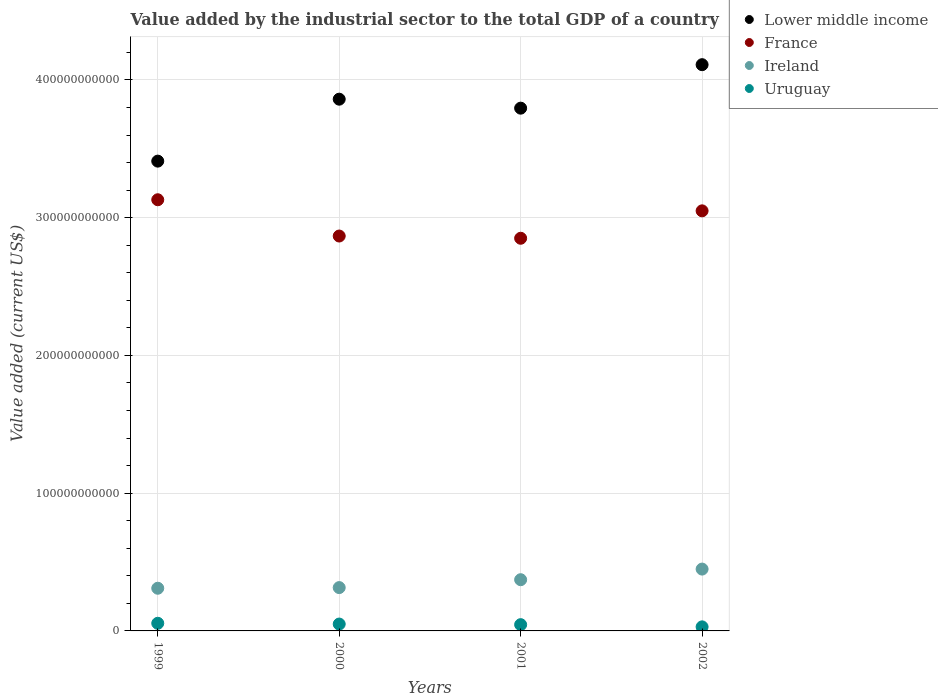How many different coloured dotlines are there?
Offer a terse response. 4. What is the value added by the industrial sector to the total GDP in Lower middle income in 2001?
Offer a terse response. 3.79e+11. Across all years, what is the maximum value added by the industrial sector to the total GDP in Lower middle income?
Keep it short and to the point. 4.11e+11. Across all years, what is the minimum value added by the industrial sector to the total GDP in Uruguay?
Provide a succinct answer. 2.95e+09. In which year was the value added by the industrial sector to the total GDP in Uruguay maximum?
Offer a terse response. 1999. In which year was the value added by the industrial sector to the total GDP in France minimum?
Ensure brevity in your answer.  2001. What is the total value added by the industrial sector to the total GDP in Uruguay in the graph?
Provide a succinct answer. 1.80e+1. What is the difference between the value added by the industrial sector to the total GDP in Lower middle income in 1999 and that in 2002?
Offer a very short reply. -7.00e+1. What is the difference between the value added by the industrial sector to the total GDP in Uruguay in 2002 and the value added by the industrial sector to the total GDP in Lower middle income in 1999?
Offer a very short reply. -3.38e+11. What is the average value added by the industrial sector to the total GDP in Uruguay per year?
Make the answer very short. 4.50e+09. In the year 2001, what is the difference between the value added by the industrial sector to the total GDP in Lower middle income and value added by the industrial sector to the total GDP in France?
Your response must be concise. 9.44e+1. What is the ratio of the value added by the industrial sector to the total GDP in Ireland in 1999 to that in 2001?
Your answer should be compact. 0.83. Is the value added by the industrial sector to the total GDP in Uruguay in 1999 less than that in 2000?
Your answer should be compact. No. What is the difference between the highest and the second highest value added by the industrial sector to the total GDP in Ireland?
Give a very brief answer. 7.71e+09. What is the difference between the highest and the lowest value added by the industrial sector to the total GDP in Uruguay?
Provide a succinct answer. 2.59e+09. Is the sum of the value added by the industrial sector to the total GDP in Lower middle income in 1999 and 2002 greater than the maximum value added by the industrial sector to the total GDP in France across all years?
Your response must be concise. Yes. Is it the case that in every year, the sum of the value added by the industrial sector to the total GDP in Lower middle income and value added by the industrial sector to the total GDP in France  is greater than the sum of value added by the industrial sector to the total GDP in Ireland and value added by the industrial sector to the total GDP in Uruguay?
Ensure brevity in your answer.  Yes. Is it the case that in every year, the sum of the value added by the industrial sector to the total GDP in Uruguay and value added by the industrial sector to the total GDP in France  is greater than the value added by the industrial sector to the total GDP in Ireland?
Ensure brevity in your answer.  Yes. Does the value added by the industrial sector to the total GDP in France monotonically increase over the years?
Provide a short and direct response. No. Is the value added by the industrial sector to the total GDP in Lower middle income strictly less than the value added by the industrial sector to the total GDP in Uruguay over the years?
Offer a terse response. No. What is the difference between two consecutive major ticks on the Y-axis?
Your answer should be very brief. 1.00e+11. Does the graph contain any zero values?
Provide a succinct answer. No. How are the legend labels stacked?
Your answer should be compact. Vertical. What is the title of the graph?
Provide a short and direct response. Value added by the industrial sector to the total GDP of a country. What is the label or title of the Y-axis?
Keep it short and to the point. Value added (current US$). What is the Value added (current US$) of Lower middle income in 1999?
Give a very brief answer. 3.41e+11. What is the Value added (current US$) in France in 1999?
Your response must be concise. 3.13e+11. What is the Value added (current US$) in Ireland in 1999?
Give a very brief answer. 3.10e+1. What is the Value added (current US$) of Uruguay in 1999?
Offer a terse response. 5.54e+09. What is the Value added (current US$) of Lower middle income in 2000?
Make the answer very short. 3.86e+11. What is the Value added (current US$) in France in 2000?
Make the answer very short. 2.87e+11. What is the Value added (current US$) in Ireland in 2000?
Offer a very short reply. 3.15e+1. What is the Value added (current US$) in Uruguay in 2000?
Keep it short and to the point. 4.98e+09. What is the Value added (current US$) of Lower middle income in 2001?
Give a very brief answer. 3.79e+11. What is the Value added (current US$) in France in 2001?
Give a very brief answer. 2.85e+11. What is the Value added (current US$) of Ireland in 2001?
Ensure brevity in your answer.  3.72e+1. What is the Value added (current US$) in Uruguay in 2001?
Your answer should be very brief. 4.54e+09. What is the Value added (current US$) of Lower middle income in 2002?
Your response must be concise. 4.11e+11. What is the Value added (current US$) of France in 2002?
Offer a very short reply. 3.05e+11. What is the Value added (current US$) of Ireland in 2002?
Ensure brevity in your answer.  4.49e+1. What is the Value added (current US$) of Uruguay in 2002?
Keep it short and to the point. 2.95e+09. Across all years, what is the maximum Value added (current US$) in Lower middle income?
Your answer should be very brief. 4.11e+11. Across all years, what is the maximum Value added (current US$) of France?
Offer a terse response. 3.13e+11. Across all years, what is the maximum Value added (current US$) in Ireland?
Your answer should be compact. 4.49e+1. Across all years, what is the maximum Value added (current US$) in Uruguay?
Offer a very short reply. 5.54e+09. Across all years, what is the minimum Value added (current US$) of Lower middle income?
Provide a succinct answer. 3.41e+11. Across all years, what is the minimum Value added (current US$) in France?
Offer a very short reply. 2.85e+11. Across all years, what is the minimum Value added (current US$) of Ireland?
Offer a terse response. 3.10e+1. Across all years, what is the minimum Value added (current US$) in Uruguay?
Provide a succinct answer. 2.95e+09. What is the total Value added (current US$) of Lower middle income in the graph?
Give a very brief answer. 1.52e+12. What is the total Value added (current US$) of France in the graph?
Provide a short and direct response. 1.19e+12. What is the total Value added (current US$) of Ireland in the graph?
Give a very brief answer. 1.45e+11. What is the total Value added (current US$) in Uruguay in the graph?
Ensure brevity in your answer.  1.80e+1. What is the difference between the Value added (current US$) in Lower middle income in 1999 and that in 2000?
Provide a succinct answer. -4.50e+1. What is the difference between the Value added (current US$) in France in 1999 and that in 2000?
Make the answer very short. 2.63e+1. What is the difference between the Value added (current US$) of Ireland in 1999 and that in 2000?
Your answer should be very brief. -4.74e+08. What is the difference between the Value added (current US$) of Uruguay in 1999 and that in 2000?
Give a very brief answer. 5.58e+08. What is the difference between the Value added (current US$) of Lower middle income in 1999 and that in 2001?
Provide a succinct answer. -3.84e+1. What is the difference between the Value added (current US$) of France in 1999 and that in 2001?
Offer a very short reply. 2.80e+1. What is the difference between the Value added (current US$) in Ireland in 1999 and that in 2001?
Keep it short and to the point. -6.20e+09. What is the difference between the Value added (current US$) of Uruguay in 1999 and that in 2001?
Ensure brevity in your answer.  9.97e+08. What is the difference between the Value added (current US$) of Lower middle income in 1999 and that in 2002?
Offer a terse response. -7.00e+1. What is the difference between the Value added (current US$) of France in 1999 and that in 2002?
Your answer should be compact. 8.05e+09. What is the difference between the Value added (current US$) of Ireland in 1999 and that in 2002?
Make the answer very short. -1.39e+1. What is the difference between the Value added (current US$) in Uruguay in 1999 and that in 2002?
Offer a terse response. 2.59e+09. What is the difference between the Value added (current US$) in Lower middle income in 2000 and that in 2001?
Offer a terse response. 6.52e+09. What is the difference between the Value added (current US$) of France in 2000 and that in 2001?
Offer a very short reply. 1.62e+09. What is the difference between the Value added (current US$) of Ireland in 2000 and that in 2001?
Give a very brief answer. -5.73e+09. What is the difference between the Value added (current US$) in Uruguay in 2000 and that in 2001?
Provide a short and direct response. 4.39e+08. What is the difference between the Value added (current US$) in Lower middle income in 2000 and that in 2002?
Offer a very short reply. -2.50e+1. What is the difference between the Value added (current US$) of France in 2000 and that in 2002?
Ensure brevity in your answer.  -1.83e+1. What is the difference between the Value added (current US$) in Ireland in 2000 and that in 2002?
Provide a short and direct response. -1.34e+1. What is the difference between the Value added (current US$) in Uruguay in 2000 and that in 2002?
Give a very brief answer. 2.04e+09. What is the difference between the Value added (current US$) of Lower middle income in 2001 and that in 2002?
Ensure brevity in your answer.  -3.16e+1. What is the difference between the Value added (current US$) of France in 2001 and that in 2002?
Keep it short and to the point. -1.99e+1. What is the difference between the Value added (current US$) in Ireland in 2001 and that in 2002?
Provide a succinct answer. -7.71e+09. What is the difference between the Value added (current US$) in Uruguay in 2001 and that in 2002?
Make the answer very short. 1.60e+09. What is the difference between the Value added (current US$) of Lower middle income in 1999 and the Value added (current US$) of France in 2000?
Your response must be concise. 5.44e+1. What is the difference between the Value added (current US$) in Lower middle income in 1999 and the Value added (current US$) in Ireland in 2000?
Ensure brevity in your answer.  3.10e+11. What is the difference between the Value added (current US$) of Lower middle income in 1999 and the Value added (current US$) of Uruguay in 2000?
Offer a very short reply. 3.36e+11. What is the difference between the Value added (current US$) in France in 1999 and the Value added (current US$) in Ireland in 2000?
Make the answer very short. 2.82e+11. What is the difference between the Value added (current US$) of France in 1999 and the Value added (current US$) of Uruguay in 2000?
Offer a terse response. 3.08e+11. What is the difference between the Value added (current US$) of Ireland in 1999 and the Value added (current US$) of Uruguay in 2000?
Make the answer very short. 2.60e+1. What is the difference between the Value added (current US$) in Lower middle income in 1999 and the Value added (current US$) in France in 2001?
Your answer should be very brief. 5.60e+1. What is the difference between the Value added (current US$) of Lower middle income in 1999 and the Value added (current US$) of Ireland in 2001?
Your answer should be very brief. 3.04e+11. What is the difference between the Value added (current US$) of Lower middle income in 1999 and the Value added (current US$) of Uruguay in 2001?
Offer a terse response. 3.37e+11. What is the difference between the Value added (current US$) of France in 1999 and the Value added (current US$) of Ireland in 2001?
Give a very brief answer. 2.76e+11. What is the difference between the Value added (current US$) of France in 1999 and the Value added (current US$) of Uruguay in 2001?
Keep it short and to the point. 3.08e+11. What is the difference between the Value added (current US$) of Ireland in 1999 and the Value added (current US$) of Uruguay in 2001?
Offer a terse response. 2.64e+1. What is the difference between the Value added (current US$) of Lower middle income in 1999 and the Value added (current US$) of France in 2002?
Offer a very short reply. 3.61e+1. What is the difference between the Value added (current US$) of Lower middle income in 1999 and the Value added (current US$) of Ireland in 2002?
Provide a succinct answer. 2.96e+11. What is the difference between the Value added (current US$) in Lower middle income in 1999 and the Value added (current US$) in Uruguay in 2002?
Make the answer very short. 3.38e+11. What is the difference between the Value added (current US$) in France in 1999 and the Value added (current US$) in Ireland in 2002?
Your answer should be very brief. 2.68e+11. What is the difference between the Value added (current US$) in France in 1999 and the Value added (current US$) in Uruguay in 2002?
Your answer should be very brief. 3.10e+11. What is the difference between the Value added (current US$) in Ireland in 1999 and the Value added (current US$) in Uruguay in 2002?
Ensure brevity in your answer.  2.80e+1. What is the difference between the Value added (current US$) of Lower middle income in 2000 and the Value added (current US$) of France in 2001?
Your answer should be compact. 1.01e+11. What is the difference between the Value added (current US$) in Lower middle income in 2000 and the Value added (current US$) in Ireland in 2001?
Give a very brief answer. 3.49e+11. What is the difference between the Value added (current US$) of Lower middle income in 2000 and the Value added (current US$) of Uruguay in 2001?
Keep it short and to the point. 3.81e+11. What is the difference between the Value added (current US$) in France in 2000 and the Value added (current US$) in Ireland in 2001?
Your answer should be very brief. 2.49e+11. What is the difference between the Value added (current US$) in France in 2000 and the Value added (current US$) in Uruguay in 2001?
Provide a succinct answer. 2.82e+11. What is the difference between the Value added (current US$) in Ireland in 2000 and the Value added (current US$) in Uruguay in 2001?
Provide a short and direct response. 2.69e+1. What is the difference between the Value added (current US$) in Lower middle income in 2000 and the Value added (current US$) in France in 2002?
Your answer should be very brief. 8.11e+1. What is the difference between the Value added (current US$) of Lower middle income in 2000 and the Value added (current US$) of Ireland in 2002?
Your answer should be compact. 3.41e+11. What is the difference between the Value added (current US$) in Lower middle income in 2000 and the Value added (current US$) in Uruguay in 2002?
Give a very brief answer. 3.83e+11. What is the difference between the Value added (current US$) of France in 2000 and the Value added (current US$) of Ireland in 2002?
Your answer should be very brief. 2.42e+11. What is the difference between the Value added (current US$) in France in 2000 and the Value added (current US$) in Uruguay in 2002?
Offer a very short reply. 2.84e+11. What is the difference between the Value added (current US$) in Ireland in 2000 and the Value added (current US$) in Uruguay in 2002?
Offer a very short reply. 2.85e+1. What is the difference between the Value added (current US$) of Lower middle income in 2001 and the Value added (current US$) of France in 2002?
Your answer should be compact. 7.45e+1. What is the difference between the Value added (current US$) of Lower middle income in 2001 and the Value added (current US$) of Ireland in 2002?
Give a very brief answer. 3.35e+11. What is the difference between the Value added (current US$) in Lower middle income in 2001 and the Value added (current US$) in Uruguay in 2002?
Ensure brevity in your answer.  3.77e+11. What is the difference between the Value added (current US$) of France in 2001 and the Value added (current US$) of Ireland in 2002?
Keep it short and to the point. 2.40e+11. What is the difference between the Value added (current US$) of France in 2001 and the Value added (current US$) of Uruguay in 2002?
Make the answer very short. 2.82e+11. What is the difference between the Value added (current US$) of Ireland in 2001 and the Value added (current US$) of Uruguay in 2002?
Offer a terse response. 3.42e+1. What is the average Value added (current US$) in Lower middle income per year?
Your answer should be compact. 3.79e+11. What is the average Value added (current US$) in France per year?
Keep it short and to the point. 2.97e+11. What is the average Value added (current US$) in Ireland per year?
Keep it short and to the point. 3.61e+1. What is the average Value added (current US$) in Uruguay per year?
Ensure brevity in your answer.  4.50e+09. In the year 1999, what is the difference between the Value added (current US$) of Lower middle income and Value added (current US$) of France?
Offer a terse response. 2.80e+1. In the year 1999, what is the difference between the Value added (current US$) in Lower middle income and Value added (current US$) in Ireland?
Offer a terse response. 3.10e+11. In the year 1999, what is the difference between the Value added (current US$) in Lower middle income and Value added (current US$) in Uruguay?
Give a very brief answer. 3.36e+11. In the year 1999, what is the difference between the Value added (current US$) of France and Value added (current US$) of Ireland?
Your response must be concise. 2.82e+11. In the year 1999, what is the difference between the Value added (current US$) in France and Value added (current US$) in Uruguay?
Ensure brevity in your answer.  3.07e+11. In the year 1999, what is the difference between the Value added (current US$) of Ireland and Value added (current US$) of Uruguay?
Make the answer very short. 2.54e+1. In the year 2000, what is the difference between the Value added (current US$) of Lower middle income and Value added (current US$) of France?
Give a very brief answer. 9.93e+1. In the year 2000, what is the difference between the Value added (current US$) in Lower middle income and Value added (current US$) in Ireland?
Your answer should be compact. 3.55e+11. In the year 2000, what is the difference between the Value added (current US$) in Lower middle income and Value added (current US$) in Uruguay?
Your answer should be very brief. 3.81e+11. In the year 2000, what is the difference between the Value added (current US$) of France and Value added (current US$) of Ireland?
Ensure brevity in your answer.  2.55e+11. In the year 2000, what is the difference between the Value added (current US$) in France and Value added (current US$) in Uruguay?
Your response must be concise. 2.82e+11. In the year 2000, what is the difference between the Value added (current US$) in Ireland and Value added (current US$) in Uruguay?
Provide a short and direct response. 2.65e+1. In the year 2001, what is the difference between the Value added (current US$) in Lower middle income and Value added (current US$) in France?
Make the answer very short. 9.44e+1. In the year 2001, what is the difference between the Value added (current US$) in Lower middle income and Value added (current US$) in Ireland?
Provide a short and direct response. 3.42e+11. In the year 2001, what is the difference between the Value added (current US$) of Lower middle income and Value added (current US$) of Uruguay?
Keep it short and to the point. 3.75e+11. In the year 2001, what is the difference between the Value added (current US$) in France and Value added (current US$) in Ireland?
Provide a succinct answer. 2.48e+11. In the year 2001, what is the difference between the Value added (current US$) in France and Value added (current US$) in Uruguay?
Provide a short and direct response. 2.81e+11. In the year 2001, what is the difference between the Value added (current US$) of Ireland and Value added (current US$) of Uruguay?
Offer a terse response. 3.26e+1. In the year 2002, what is the difference between the Value added (current US$) of Lower middle income and Value added (current US$) of France?
Provide a succinct answer. 1.06e+11. In the year 2002, what is the difference between the Value added (current US$) of Lower middle income and Value added (current US$) of Ireland?
Ensure brevity in your answer.  3.66e+11. In the year 2002, what is the difference between the Value added (current US$) in Lower middle income and Value added (current US$) in Uruguay?
Make the answer very short. 4.08e+11. In the year 2002, what is the difference between the Value added (current US$) in France and Value added (current US$) in Ireland?
Provide a short and direct response. 2.60e+11. In the year 2002, what is the difference between the Value added (current US$) of France and Value added (current US$) of Uruguay?
Give a very brief answer. 3.02e+11. In the year 2002, what is the difference between the Value added (current US$) of Ireland and Value added (current US$) of Uruguay?
Offer a very short reply. 4.19e+1. What is the ratio of the Value added (current US$) of Lower middle income in 1999 to that in 2000?
Your answer should be compact. 0.88. What is the ratio of the Value added (current US$) of France in 1999 to that in 2000?
Keep it short and to the point. 1.09. What is the ratio of the Value added (current US$) of Ireland in 1999 to that in 2000?
Give a very brief answer. 0.98. What is the ratio of the Value added (current US$) of Uruguay in 1999 to that in 2000?
Your answer should be very brief. 1.11. What is the ratio of the Value added (current US$) in Lower middle income in 1999 to that in 2001?
Your response must be concise. 0.9. What is the ratio of the Value added (current US$) of France in 1999 to that in 2001?
Make the answer very short. 1.1. What is the ratio of the Value added (current US$) of Uruguay in 1999 to that in 2001?
Your response must be concise. 1.22. What is the ratio of the Value added (current US$) of Lower middle income in 1999 to that in 2002?
Keep it short and to the point. 0.83. What is the ratio of the Value added (current US$) of France in 1999 to that in 2002?
Keep it short and to the point. 1.03. What is the ratio of the Value added (current US$) of Ireland in 1999 to that in 2002?
Your response must be concise. 0.69. What is the ratio of the Value added (current US$) of Uruguay in 1999 to that in 2002?
Give a very brief answer. 1.88. What is the ratio of the Value added (current US$) in Lower middle income in 2000 to that in 2001?
Provide a succinct answer. 1.02. What is the ratio of the Value added (current US$) of France in 2000 to that in 2001?
Ensure brevity in your answer.  1.01. What is the ratio of the Value added (current US$) in Ireland in 2000 to that in 2001?
Make the answer very short. 0.85. What is the ratio of the Value added (current US$) of Uruguay in 2000 to that in 2001?
Provide a succinct answer. 1.1. What is the ratio of the Value added (current US$) of Lower middle income in 2000 to that in 2002?
Offer a very short reply. 0.94. What is the ratio of the Value added (current US$) of France in 2000 to that in 2002?
Offer a very short reply. 0.94. What is the ratio of the Value added (current US$) in Ireland in 2000 to that in 2002?
Your answer should be compact. 0.7. What is the ratio of the Value added (current US$) of Uruguay in 2000 to that in 2002?
Provide a short and direct response. 1.69. What is the ratio of the Value added (current US$) in Lower middle income in 2001 to that in 2002?
Give a very brief answer. 0.92. What is the ratio of the Value added (current US$) of France in 2001 to that in 2002?
Keep it short and to the point. 0.93. What is the ratio of the Value added (current US$) in Ireland in 2001 to that in 2002?
Keep it short and to the point. 0.83. What is the ratio of the Value added (current US$) of Uruguay in 2001 to that in 2002?
Offer a very short reply. 1.54. What is the difference between the highest and the second highest Value added (current US$) of Lower middle income?
Provide a succinct answer. 2.50e+1. What is the difference between the highest and the second highest Value added (current US$) of France?
Give a very brief answer. 8.05e+09. What is the difference between the highest and the second highest Value added (current US$) of Ireland?
Make the answer very short. 7.71e+09. What is the difference between the highest and the second highest Value added (current US$) in Uruguay?
Provide a short and direct response. 5.58e+08. What is the difference between the highest and the lowest Value added (current US$) of Lower middle income?
Ensure brevity in your answer.  7.00e+1. What is the difference between the highest and the lowest Value added (current US$) of France?
Make the answer very short. 2.80e+1. What is the difference between the highest and the lowest Value added (current US$) of Ireland?
Make the answer very short. 1.39e+1. What is the difference between the highest and the lowest Value added (current US$) of Uruguay?
Give a very brief answer. 2.59e+09. 